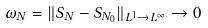<formula> <loc_0><loc_0><loc_500><loc_500>\omega _ { N } = \| S _ { N } - S _ { N _ { 0 } } \| _ { L ^ { 1 } \to L ^ { \infty } } \to 0</formula> 